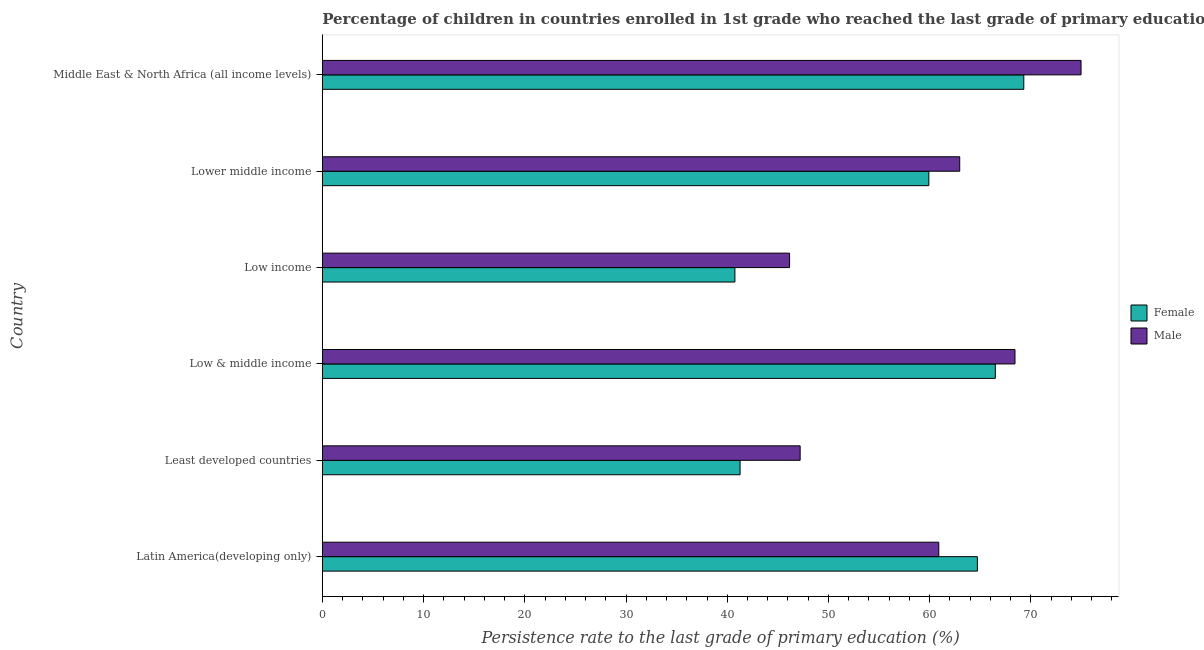How many different coloured bars are there?
Keep it short and to the point. 2. How many groups of bars are there?
Keep it short and to the point. 6. Are the number of bars per tick equal to the number of legend labels?
Provide a succinct answer. Yes. Are the number of bars on each tick of the Y-axis equal?
Give a very brief answer. Yes. How many bars are there on the 4th tick from the bottom?
Ensure brevity in your answer.  2. What is the label of the 5th group of bars from the top?
Offer a terse response. Least developed countries. In how many cases, is the number of bars for a given country not equal to the number of legend labels?
Your answer should be compact. 0. What is the persistence rate of male students in Least developed countries?
Ensure brevity in your answer.  47.2. Across all countries, what is the maximum persistence rate of female students?
Provide a short and direct response. 69.29. Across all countries, what is the minimum persistence rate of male students?
Provide a succinct answer. 46.16. In which country was the persistence rate of female students maximum?
Make the answer very short. Middle East & North Africa (all income levels). In which country was the persistence rate of female students minimum?
Give a very brief answer. Low income. What is the total persistence rate of female students in the graph?
Offer a terse response. 342.42. What is the difference between the persistence rate of male students in Least developed countries and that in Middle East & North Africa (all income levels)?
Your answer should be very brief. -27.75. What is the difference between the persistence rate of male students in Low & middle income and the persistence rate of female students in Least developed countries?
Give a very brief answer. 27.16. What is the average persistence rate of male students per country?
Offer a terse response. 60.1. What is the difference between the persistence rate of female students and persistence rate of male students in Lower middle income?
Offer a very short reply. -3.05. Is the difference between the persistence rate of female students in Latin America(developing only) and Low income greater than the difference between the persistence rate of male students in Latin America(developing only) and Low income?
Give a very brief answer. Yes. What is the difference between the highest and the second highest persistence rate of female students?
Provide a succinct answer. 2.81. What is the difference between the highest and the lowest persistence rate of female students?
Your response must be concise. 28.54. Is the sum of the persistence rate of male students in Latin America(developing only) and Least developed countries greater than the maximum persistence rate of female students across all countries?
Ensure brevity in your answer.  Yes. Are all the bars in the graph horizontal?
Your answer should be very brief. Yes. Are the values on the major ticks of X-axis written in scientific E-notation?
Provide a short and direct response. No. Does the graph contain any zero values?
Your answer should be very brief. No. How many legend labels are there?
Offer a terse response. 2. What is the title of the graph?
Offer a very short reply. Percentage of children in countries enrolled in 1st grade who reached the last grade of primary education. Does "From human activities" appear as one of the legend labels in the graph?
Offer a terse response. No. What is the label or title of the X-axis?
Offer a terse response. Persistence rate to the last grade of primary education (%). What is the Persistence rate to the last grade of primary education (%) in Female in Latin America(developing only)?
Give a very brief answer. 64.71. What is the Persistence rate to the last grade of primary education (%) in Male in Latin America(developing only)?
Offer a terse response. 60.9. What is the Persistence rate to the last grade of primary education (%) in Female in Least developed countries?
Give a very brief answer. 41.27. What is the Persistence rate to the last grade of primary education (%) in Male in Least developed countries?
Your answer should be compact. 47.2. What is the Persistence rate to the last grade of primary education (%) of Female in Low & middle income?
Keep it short and to the point. 66.48. What is the Persistence rate to the last grade of primary education (%) of Male in Low & middle income?
Give a very brief answer. 68.42. What is the Persistence rate to the last grade of primary education (%) of Female in Low income?
Your answer should be very brief. 40.76. What is the Persistence rate to the last grade of primary education (%) in Male in Low income?
Offer a very short reply. 46.16. What is the Persistence rate to the last grade of primary education (%) of Female in Lower middle income?
Provide a succinct answer. 59.91. What is the Persistence rate to the last grade of primary education (%) in Male in Lower middle income?
Keep it short and to the point. 62.96. What is the Persistence rate to the last grade of primary education (%) of Female in Middle East & North Africa (all income levels)?
Your answer should be very brief. 69.29. What is the Persistence rate to the last grade of primary education (%) in Male in Middle East & North Africa (all income levels)?
Offer a very short reply. 74.95. Across all countries, what is the maximum Persistence rate to the last grade of primary education (%) in Female?
Your response must be concise. 69.29. Across all countries, what is the maximum Persistence rate to the last grade of primary education (%) of Male?
Keep it short and to the point. 74.95. Across all countries, what is the minimum Persistence rate to the last grade of primary education (%) in Female?
Offer a terse response. 40.76. Across all countries, what is the minimum Persistence rate to the last grade of primary education (%) of Male?
Your answer should be very brief. 46.16. What is the total Persistence rate to the last grade of primary education (%) in Female in the graph?
Your response must be concise. 342.42. What is the total Persistence rate to the last grade of primary education (%) of Male in the graph?
Provide a succinct answer. 360.59. What is the difference between the Persistence rate to the last grade of primary education (%) of Female in Latin America(developing only) and that in Least developed countries?
Give a very brief answer. 23.44. What is the difference between the Persistence rate to the last grade of primary education (%) in Male in Latin America(developing only) and that in Least developed countries?
Give a very brief answer. 13.7. What is the difference between the Persistence rate to the last grade of primary education (%) in Female in Latin America(developing only) and that in Low & middle income?
Your response must be concise. -1.77. What is the difference between the Persistence rate to the last grade of primary education (%) of Male in Latin America(developing only) and that in Low & middle income?
Offer a terse response. -7.53. What is the difference between the Persistence rate to the last grade of primary education (%) in Female in Latin America(developing only) and that in Low income?
Give a very brief answer. 23.95. What is the difference between the Persistence rate to the last grade of primary education (%) of Male in Latin America(developing only) and that in Low income?
Provide a succinct answer. 14.74. What is the difference between the Persistence rate to the last grade of primary education (%) of Female in Latin America(developing only) and that in Lower middle income?
Offer a very short reply. 4.8. What is the difference between the Persistence rate to the last grade of primary education (%) in Male in Latin America(developing only) and that in Lower middle income?
Give a very brief answer. -2.07. What is the difference between the Persistence rate to the last grade of primary education (%) in Female in Latin America(developing only) and that in Middle East & North Africa (all income levels)?
Keep it short and to the point. -4.59. What is the difference between the Persistence rate to the last grade of primary education (%) in Male in Latin America(developing only) and that in Middle East & North Africa (all income levels)?
Make the answer very short. -14.05. What is the difference between the Persistence rate to the last grade of primary education (%) of Female in Least developed countries and that in Low & middle income?
Your response must be concise. -25.21. What is the difference between the Persistence rate to the last grade of primary education (%) in Male in Least developed countries and that in Low & middle income?
Your answer should be compact. -21.22. What is the difference between the Persistence rate to the last grade of primary education (%) of Female in Least developed countries and that in Low income?
Ensure brevity in your answer.  0.51. What is the difference between the Persistence rate to the last grade of primary education (%) in Male in Least developed countries and that in Low income?
Make the answer very short. 1.04. What is the difference between the Persistence rate to the last grade of primary education (%) of Female in Least developed countries and that in Lower middle income?
Provide a succinct answer. -18.64. What is the difference between the Persistence rate to the last grade of primary education (%) in Male in Least developed countries and that in Lower middle income?
Your response must be concise. -15.76. What is the difference between the Persistence rate to the last grade of primary education (%) of Female in Least developed countries and that in Middle East & North Africa (all income levels)?
Provide a short and direct response. -28.03. What is the difference between the Persistence rate to the last grade of primary education (%) in Male in Least developed countries and that in Middle East & North Africa (all income levels)?
Your answer should be very brief. -27.75. What is the difference between the Persistence rate to the last grade of primary education (%) in Female in Low & middle income and that in Low income?
Your answer should be compact. 25.73. What is the difference between the Persistence rate to the last grade of primary education (%) in Male in Low & middle income and that in Low income?
Keep it short and to the point. 22.27. What is the difference between the Persistence rate to the last grade of primary education (%) of Female in Low & middle income and that in Lower middle income?
Keep it short and to the point. 6.57. What is the difference between the Persistence rate to the last grade of primary education (%) in Male in Low & middle income and that in Lower middle income?
Your response must be concise. 5.46. What is the difference between the Persistence rate to the last grade of primary education (%) in Female in Low & middle income and that in Middle East & North Africa (all income levels)?
Your answer should be compact. -2.81. What is the difference between the Persistence rate to the last grade of primary education (%) of Male in Low & middle income and that in Middle East & North Africa (all income levels)?
Your answer should be very brief. -6.53. What is the difference between the Persistence rate to the last grade of primary education (%) in Female in Low income and that in Lower middle income?
Make the answer very short. -19.16. What is the difference between the Persistence rate to the last grade of primary education (%) in Male in Low income and that in Lower middle income?
Offer a very short reply. -16.81. What is the difference between the Persistence rate to the last grade of primary education (%) of Female in Low income and that in Middle East & North Africa (all income levels)?
Keep it short and to the point. -28.54. What is the difference between the Persistence rate to the last grade of primary education (%) in Male in Low income and that in Middle East & North Africa (all income levels)?
Keep it short and to the point. -28.79. What is the difference between the Persistence rate to the last grade of primary education (%) in Female in Lower middle income and that in Middle East & North Africa (all income levels)?
Your response must be concise. -9.38. What is the difference between the Persistence rate to the last grade of primary education (%) of Male in Lower middle income and that in Middle East & North Africa (all income levels)?
Your answer should be very brief. -11.99. What is the difference between the Persistence rate to the last grade of primary education (%) in Female in Latin America(developing only) and the Persistence rate to the last grade of primary education (%) in Male in Least developed countries?
Make the answer very short. 17.51. What is the difference between the Persistence rate to the last grade of primary education (%) in Female in Latin America(developing only) and the Persistence rate to the last grade of primary education (%) in Male in Low & middle income?
Provide a succinct answer. -3.72. What is the difference between the Persistence rate to the last grade of primary education (%) in Female in Latin America(developing only) and the Persistence rate to the last grade of primary education (%) in Male in Low income?
Provide a short and direct response. 18.55. What is the difference between the Persistence rate to the last grade of primary education (%) of Female in Latin America(developing only) and the Persistence rate to the last grade of primary education (%) of Male in Lower middle income?
Provide a short and direct response. 1.74. What is the difference between the Persistence rate to the last grade of primary education (%) of Female in Latin America(developing only) and the Persistence rate to the last grade of primary education (%) of Male in Middle East & North Africa (all income levels)?
Give a very brief answer. -10.24. What is the difference between the Persistence rate to the last grade of primary education (%) of Female in Least developed countries and the Persistence rate to the last grade of primary education (%) of Male in Low & middle income?
Offer a very short reply. -27.16. What is the difference between the Persistence rate to the last grade of primary education (%) in Female in Least developed countries and the Persistence rate to the last grade of primary education (%) in Male in Low income?
Keep it short and to the point. -4.89. What is the difference between the Persistence rate to the last grade of primary education (%) of Female in Least developed countries and the Persistence rate to the last grade of primary education (%) of Male in Lower middle income?
Provide a succinct answer. -21.7. What is the difference between the Persistence rate to the last grade of primary education (%) of Female in Least developed countries and the Persistence rate to the last grade of primary education (%) of Male in Middle East & North Africa (all income levels)?
Offer a terse response. -33.68. What is the difference between the Persistence rate to the last grade of primary education (%) in Female in Low & middle income and the Persistence rate to the last grade of primary education (%) in Male in Low income?
Make the answer very short. 20.32. What is the difference between the Persistence rate to the last grade of primary education (%) of Female in Low & middle income and the Persistence rate to the last grade of primary education (%) of Male in Lower middle income?
Provide a succinct answer. 3.52. What is the difference between the Persistence rate to the last grade of primary education (%) of Female in Low & middle income and the Persistence rate to the last grade of primary education (%) of Male in Middle East & North Africa (all income levels)?
Give a very brief answer. -8.47. What is the difference between the Persistence rate to the last grade of primary education (%) in Female in Low income and the Persistence rate to the last grade of primary education (%) in Male in Lower middle income?
Offer a terse response. -22.21. What is the difference between the Persistence rate to the last grade of primary education (%) in Female in Low income and the Persistence rate to the last grade of primary education (%) in Male in Middle East & North Africa (all income levels)?
Ensure brevity in your answer.  -34.19. What is the difference between the Persistence rate to the last grade of primary education (%) in Female in Lower middle income and the Persistence rate to the last grade of primary education (%) in Male in Middle East & North Africa (all income levels)?
Provide a short and direct response. -15.04. What is the average Persistence rate to the last grade of primary education (%) in Female per country?
Ensure brevity in your answer.  57.07. What is the average Persistence rate to the last grade of primary education (%) of Male per country?
Give a very brief answer. 60.1. What is the difference between the Persistence rate to the last grade of primary education (%) of Female and Persistence rate to the last grade of primary education (%) of Male in Latin America(developing only)?
Ensure brevity in your answer.  3.81. What is the difference between the Persistence rate to the last grade of primary education (%) in Female and Persistence rate to the last grade of primary education (%) in Male in Least developed countries?
Your response must be concise. -5.93. What is the difference between the Persistence rate to the last grade of primary education (%) in Female and Persistence rate to the last grade of primary education (%) in Male in Low & middle income?
Keep it short and to the point. -1.94. What is the difference between the Persistence rate to the last grade of primary education (%) of Female and Persistence rate to the last grade of primary education (%) of Male in Low income?
Offer a very short reply. -5.4. What is the difference between the Persistence rate to the last grade of primary education (%) of Female and Persistence rate to the last grade of primary education (%) of Male in Lower middle income?
Your answer should be very brief. -3.05. What is the difference between the Persistence rate to the last grade of primary education (%) in Female and Persistence rate to the last grade of primary education (%) in Male in Middle East & North Africa (all income levels)?
Keep it short and to the point. -5.65. What is the ratio of the Persistence rate to the last grade of primary education (%) in Female in Latin America(developing only) to that in Least developed countries?
Offer a very short reply. 1.57. What is the ratio of the Persistence rate to the last grade of primary education (%) in Male in Latin America(developing only) to that in Least developed countries?
Offer a very short reply. 1.29. What is the ratio of the Persistence rate to the last grade of primary education (%) in Female in Latin America(developing only) to that in Low & middle income?
Your answer should be very brief. 0.97. What is the ratio of the Persistence rate to the last grade of primary education (%) of Male in Latin America(developing only) to that in Low & middle income?
Keep it short and to the point. 0.89. What is the ratio of the Persistence rate to the last grade of primary education (%) of Female in Latin America(developing only) to that in Low income?
Offer a terse response. 1.59. What is the ratio of the Persistence rate to the last grade of primary education (%) of Male in Latin America(developing only) to that in Low income?
Provide a succinct answer. 1.32. What is the ratio of the Persistence rate to the last grade of primary education (%) of Male in Latin America(developing only) to that in Lower middle income?
Ensure brevity in your answer.  0.97. What is the ratio of the Persistence rate to the last grade of primary education (%) in Female in Latin America(developing only) to that in Middle East & North Africa (all income levels)?
Give a very brief answer. 0.93. What is the ratio of the Persistence rate to the last grade of primary education (%) of Male in Latin America(developing only) to that in Middle East & North Africa (all income levels)?
Ensure brevity in your answer.  0.81. What is the ratio of the Persistence rate to the last grade of primary education (%) in Female in Least developed countries to that in Low & middle income?
Make the answer very short. 0.62. What is the ratio of the Persistence rate to the last grade of primary education (%) of Male in Least developed countries to that in Low & middle income?
Offer a terse response. 0.69. What is the ratio of the Persistence rate to the last grade of primary education (%) of Female in Least developed countries to that in Low income?
Keep it short and to the point. 1.01. What is the ratio of the Persistence rate to the last grade of primary education (%) in Male in Least developed countries to that in Low income?
Offer a very short reply. 1.02. What is the ratio of the Persistence rate to the last grade of primary education (%) in Female in Least developed countries to that in Lower middle income?
Give a very brief answer. 0.69. What is the ratio of the Persistence rate to the last grade of primary education (%) of Male in Least developed countries to that in Lower middle income?
Your response must be concise. 0.75. What is the ratio of the Persistence rate to the last grade of primary education (%) in Female in Least developed countries to that in Middle East & North Africa (all income levels)?
Make the answer very short. 0.6. What is the ratio of the Persistence rate to the last grade of primary education (%) in Male in Least developed countries to that in Middle East & North Africa (all income levels)?
Provide a succinct answer. 0.63. What is the ratio of the Persistence rate to the last grade of primary education (%) of Female in Low & middle income to that in Low income?
Keep it short and to the point. 1.63. What is the ratio of the Persistence rate to the last grade of primary education (%) of Male in Low & middle income to that in Low income?
Provide a short and direct response. 1.48. What is the ratio of the Persistence rate to the last grade of primary education (%) of Female in Low & middle income to that in Lower middle income?
Your response must be concise. 1.11. What is the ratio of the Persistence rate to the last grade of primary education (%) of Male in Low & middle income to that in Lower middle income?
Provide a short and direct response. 1.09. What is the ratio of the Persistence rate to the last grade of primary education (%) of Female in Low & middle income to that in Middle East & North Africa (all income levels)?
Provide a succinct answer. 0.96. What is the ratio of the Persistence rate to the last grade of primary education (%) of Male in Low & middle income to that in Middle East & North Africa (all income levels)?
Ensure brevity in your answer.  0.91. What is the ratio of the Persistence rate to the last grade of primary education (%) in Female in Low income to that in Lower middle income?
Give a very brief answer. 0.68. What is the ratio of the Persistence rate to the last grade of primary education (%) in Male in Low income to that in Lower middle income?
Your answer should be very brief. 0.73. What is the ratio of the Persistence rate to the last grade of primary education (%) of Female in Low income to that in Middle East & North Africa (all income levels)?
Make the answer very short. 0.59. What is the ratio of the Persistence rate to the last grade of primary education (%) in Male in Low income to that in Middle East & North Africa (all income levels)?
Your response must be concise. 0.62. What is the ratio of the Persistence rate to the last grade of primary education (%) in Female in Lower middle income to that in Middle East & North Africa (all income levels)?
Offer a very short reply. 0.86. What is the ratio of the Persistence rate to the last grade of primary education (%) in Male in Lower middle income to that in Middle East & North Africa (all income levels)?
Provide a short and direct response. 0.84. What is the difference between the highest and the second highest Persistence rate to the last grade of primary education (%) of Female?
Your answer should be compact. 2.81. What is the difference between the highest and the second highest Persistence rate to the last grade of primary education (%) in Male?
Offer a very short reply. 6.53. What is the difference between the highest and the lowest Persistence rate to the last grade of primary education (%) of Female?
Provide a succinct answer. 28.54. What is the difference between the highest and the lowest Persistence rate to the last grade of primary education (%) in Male?
Your answer should be compact. 28.79. 